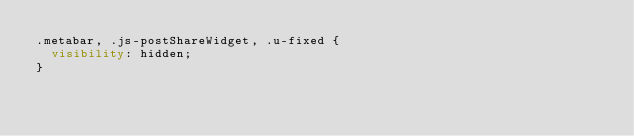Convert code to text. <code><loc_0><loc_0><loc_500><loc_500><_CSS_>.metabar, .js-postShareWidget, .u-fixed {
  visibility: hidden;
}
</code> 